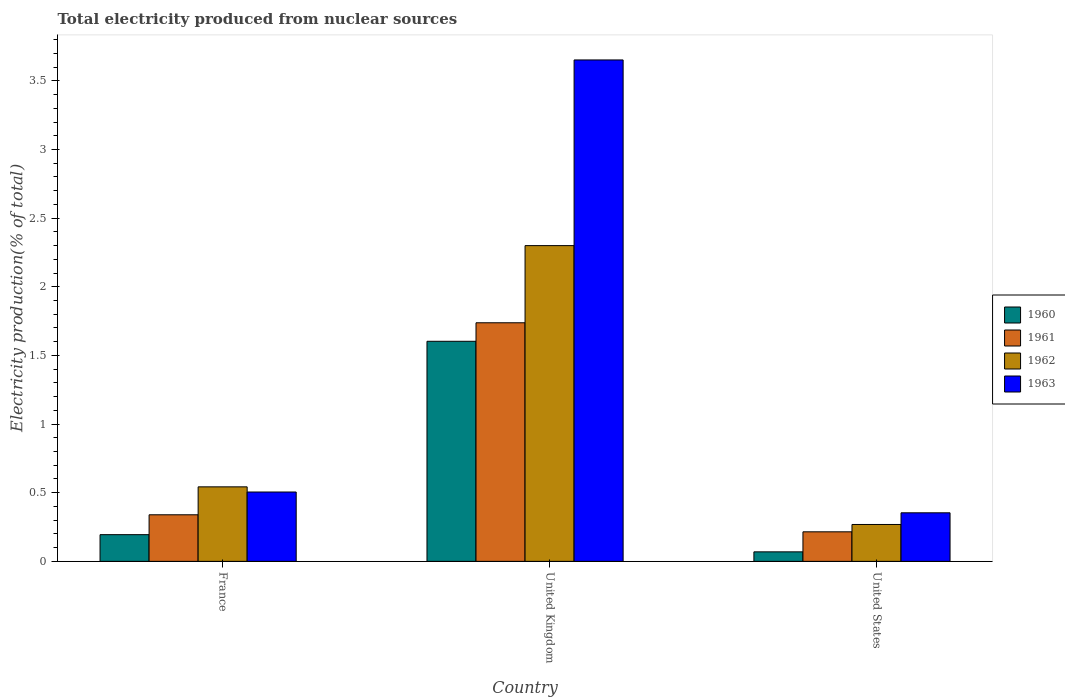How many different coloured bars are there?
Your response must be concise. 4. Are the number of bars on each tick of the X-axis equal?
Offer a terse response. Yes. In how many cases, is the number of bars for a given country not equal to the number of legend labels?
Offer a very short reply. 0. What is the total electricity produced in 1962 in United Kingdom?
Provide a short and direct response. 2.3. Across all countries, what is the maximum total electricity produced in 1962?
Give a very brief answer. 2.3. Across all countries, what is the minimum total electricity produced in 1962?
Your answer should be compact. 0.27. In which country was the total electricity produced in 1960 maximum?
Offer a very short reply. United Kingdom. What is the total total electricity produced in 1960 in the graph?
Offer a very short reply. 1.87. What is the difference between the total electricity produced in 1961 in France and that in United States?
Your answer should be very brief. 0.12. What is the difference between the total electricity produced in 1962 in France and the total electricity produced in 1961 in United Kingdom?
Provide a succinct answer. -1.2. What is the average total electricity produced in 1963 per country?
Your response must be concise. 1.5. What is the difference between the total electricity produced of/in 1961 and total electricity produced of/in 1963 in United Kingdom?
Make the answer very short. -1.91. In how many countries, is the total electricity produced in 1961 greater than 3.6 %?
Ensure brevity in your answer.  0. What is the ratio of the total electricity produced in 1962 in France to that in United States?
Give a very brief answer. 2.02. Is the difference between the total electricity produced in 1961 in United Kingdom and United States greater than the difference between the total electricity produced in 1963 in United Kingdom and United States?
Your response must be concise. No. What is the difference between the highest and the second highest total electricity produced in 1962?
Provide a short and direct response. 0.27. What is the difference between the highest and the lowest total electricity produced in 1961?
Make the answer very short. 1.52. In how many countries, is the total electricity produced in 1962 greater than the average total electricity produced in 1962 taken over all countries?
Make the answer very short. 1. How many bars are there?
Your answer should be compact. 12. What is the difference between two consecutive major ticks on the Y-axis?
Offer a very short reply. 0.5. Are the values on the major ticks of Y-axis written in scientific E-notation?
Ensure brevity in your answer.  No. Does the graph contain any zero values?
Your answer should be compact. No. Does the graph contain grids?
Ensure brevity in your answer.  No. How are the legend labels stacked?
Make the answer very short. Vertical. What is the title of the graph?
Ensure brevity in your answer.  Total electricity produced from nuclear sources. Does "2001" appear as one of the legend labels in the graph?
Provide a short and direct response. No. What is the label or title of the Y-axis?
Give a very brief answer. Electricity production(% of total). What is the Electricity production(% of total) of 1960 in France?
Offer a terse response. 0.19. What is the Electricity production(% of total) of 1961 in France?
Give a very brief answer. 0.34. What is the Electricity production(% of total) in 1962 in France?
Make the answer very short. 0.54. What is the Electricity production(% of total) in 1963 in France?
Keep it short and to the point. 0.51. What is the Electricity production(% of total) in 1960 in United Kingdom?
Provide a short and direct response. 1.6. What is the Electricity production(% of total) of 1961 in United Kingdom?
Your response must be concise. 1.74. What is the Electricity production(% of total) of 1962 in United Kingdom?
Offer a terse response. 2.3. What is the Electricity production(% of total) of 1963 in United Kingdom?
Offer a terse response. 3.65. What is the Electricity production(% of total) of 1960 in United States?
Offer a terse response. 0.07. What is the Electricity production(% of total) in 1961 in United States?
Ensure brevity in your answer.  0.22. What is the Electricity production(% of total) of 1962 in United States?
Provide a succinct answer. 0.27. What is the Electricity production(% of total) in 1963 in United States?
Provide a short and direct response. 0.35. Across all countries, what is the maximum Electricity production(% of total) of 1960?
Your response must be concise. 1.6. Across all countries, what is the maximum Electricity production(% of total) of 1961?
Ensure brevity in your answer.  1.74. Across all countries, what is the maximum Electricity production(% of total) of 1962?
Offer a very short reply. 2.3. Across all countries, what is the maximum Electricity production(% of total) of 1963?
Ensure brevity in your answer.  3.65. Across all countries, what is the minimum Electricity production(% of total) in 1960?
Make the answer very short. 0.07. Across all countries, what is the minimum Electricity production(% of total) of 1961?
Your answer should be compact. 0.22. Across all countries, what is the minimum Electricity production(% of total) of 1962?
Provide a short and direct response. 0.27. Across all countries, what is the minimum Electricity production(% of total) in 1963?
Your answer should be compact. 0.35. What is the total Electricity production(% of total) of 1960 in the graph?
Offer a very short reply. 1.87. What is the total Electricity production(% of total) in 1961 in the graph?
Your answer should be very brief. 2.29. What is the total Electricity production(% of total) in 1962 in the graph?
Offer a very short reply. 3.11. What is the total Electricity production(% of total) of 1963 in the graph?
Your answer should be compact. 4.51. What is the difference between the Electricity production(% of total) of 1960 in France and that in United Kingdom?
Your response must be concise. -1.41. What is the difference between the Electricity production(% of total) in 1961 in France and that in United Kingdom?
Offer a terse response. -1.4. What is the difference between the Electricity production(% of total) of 1962 in France and that in United Kingdom?
Offer a very short reply. -1.76. What is the difference between the Electricity production(% of total) in 1963 in France and that in United Kingdom?
Provide a short and direct response. -3.15. What is the difference between the Electricity production(% of total) of 1960 in France and that in United States?
Give a very brief answer. 0.13. What is the difference between the Electricity production(% of total) of 1961 in France and that in United States?
Provide a short and direct response. 0.12. What is the difference between the Electricity production(% of total) in 1962 in France and that in United States?
Your answer should be compact. 0.27. What is the difference between the Electricity production(% of total) in 1963 in France and that in United States?
Your answer should be very brief. 0.15. What is the difference between the Electricity production(% of total) of 1960 in United Kingdom and that in United States?
Offer a very short reply. 1.53. What is the difference between the Electricity production(% of total) in 1961 in United Kingdom and that in United States?
Your answer should be very brief. 1.52. What is the difference between the Electricity production(% of total) in 1962 in United Kingdom and that in United States?
Give a very brief answer. 2.03. What is the difference between the Electricity production(% of total) of 1963 in United Kingdom and that in United States?
Your answer should be compact. 3.3. What is the difference between the Electricity production(% of total) in 1960 in France and the Electricity production(% of total) in 1961 in United Kingdom?
Your answer should be very brief. -1.54. What is the difference between the Electricity production(% of total) in 1960 in France and the Electricity production(% of total) in 1962 in United Kingdom?
Give a very brief answer. -2.11. What is the difference between the Electricity production(% of total) in 1960 in France and the Electricity production(% of total) in 1963 in United Kingdom?
Keep it short and to the point. -3.46. What is the difference between the Electricity production(% of total) in 1961 in France and the Electricity production(% of total) in 1962 in United Kingdom?
Make the answer very short. -1.96. What is the difference between the Electricity production(% of total) in 1961 in France and the Electricity production(% of total) in 1963 in United Kingdom?
Provide a short and direct response. -3.31. What is the difference between the Electricity production(% of total) in 1962 in France and the Electricity production(% of total) in 1963 in United Kingdom?
Provide a short and direct response. -3.11. What is the difference between the Electricity production(% of total) of 1960 in France and the Electricity production(% of total) of 1961 in United States?
Your response must be concise. -0.02. What is the difference between the Electricity production(% of total) of 1960 in France and the Electricity production(% of total) of 1962 in United States?
Offer a very short reply. -0.07. What is the difference between the Electricity production(% of total) of 1960 in France and the Electricity production(% of total) of 1963 in United States?
Keep it short and to the point. -0.16. What is the difference between the Electricity production(% of total) in 1961 in France and the Electricity production(% of total) in 1962 in United States?
Ensure brevity in your answer.  0.07. What is the difference between the Electricity production(% of total) of 1961 in France and the Electricity production(% of total) of 1963 in United States?
Provide a succinct answer. -0.01. What is the difference between the Electricity production(% of total) of 1962 in France and the Electricity production(% of total) of 1963 in United States?
Provide a succinct answer. 0.19. What is the difference between the Electricity production(% of total) in 1960 in United Kingdom and the Electricity production(% of total) in 1961 in United States?
Provide a short and direct response. 1.39. What is the difference between the Electricity production(% of total) in 1960 in United Kingdom and the Electricity production(% of total) in 1962 in United States?
Your answer should be very brief. 1.33. What is the difference between the Electricity production(% of total) in 1960 in United Kingdom and the Electricity production(% of total) in 1963 in United States?
Your answer should be compact. 1.25. What is the difference between the Electricity production(% of total) in 1961 in United Kingdom and the Electricity production(% of total) in 1962 in United States?
Make the answer very short. 1.47. What is the difference between the Electricity production(% of total) in 1961 in United Kingdom and the Electricity production(% of total) in 1963 in United States?
Offer a terse response. 1.38. What is the difference between the Electricity production(% of total) in 1962 in United Kingdom and the Electricity production(% of total) in 1963 in United States?
Keep it short and to the point. 1.95. What is the average Electricity production(% of total) of 1960 per country?
Your answer should be very brief. 0.62. What is the average Electricity production(% of total) of 1961 per country?
Make the answer very short. 0.76. What is the average Electricity production(% of total) of 1962 per country?
Ensure brevity in your answer.  1.04. What is the average Electricity production(% of total) in 1963 per country?
Keep it short and to the point. 1.5. What is the difference between the Electricity production(% of total) in 1960 and Electricity production(% of total) in 1961 in France?
Ensure brevity in your answer.  -0.14. What is the difference between the Electricity production(% of total) in 1960 and Electricity production(% of total) in 1962 in France?
Offer a very short reply. -0.35. What is the difference between the Electricity production(% of total) in 1960 and Electricity production(% of total) in 1963 in France?
Give a very brief answer. -0.31. What is the difference between the Electricity production(% of total) of 1961 and Electricity production(% of total) of 1962 in France?
Keep it short and to the point. -0.2. What is the difference between the Electricity production(% of total) in 1961 and Electricity production(% of total) in 1963 in France?
Your answer should be compact. -0.17. What is the difference between the Electricity production(% of total) in 1962 and Electricity production(% of total) in 1963 in France?
Give a very brief answer. 0.04. What is the difference between the Electricity production(% of total) in 1960 and Electricity production(% of total) in 1961 in United Kingdom?
Make the answer very short. -0.13. What is the difference between the Electricity production(% of total) in 1960 and Electricity production(% of total) in 1962 in United Kingdom?
Offer a very short reply. -0.7. What is the difference between the Electricity production(% of total) in 1960 and Electricity production(% of total) in 1963 in United Kingdom?
Offer a very short reply. -2.05. What is the difference between the Electricity production(% of total) of 1961 and Electricity production(% of total) of 1962 in United Kingdom?
Provide a short and direct response. -0.56. What is the difference between the Electricity production(% of total) in 1961 and Electricity production(% of total) in 1963 in United Kingdom?
Ensure brevity in your answer.  -1.91. What is the difference between the Electricity production(% of total) of 1962 and Electricity production(% of total) of 1963 in United Kingdom?
Offer a terse response. -1.35. What is the difference between the Electricity production(% of total) of 1960 and Electricity production(% of total) of 1961 in United States?
Provide a succinct answer. -0.15. What is the difference between the Electricity production(% of total) of 1960 and Electricity production(% of total) of 1962 in United States?
Your response must be concise. -0.2. What is the difference between the Electricity production(% of total) in 1960 and Electricity production(% of total) in 1963 in United States?
Offer a very short reply. -0.28. What is the difference between the Electricity production(% of total) of 1961 and Electricity production(% of total) of 1962 in United States?
Provide a short and direct response. -0.05. What is the difference between the Electricity production(% of total) in 1961 and Electricity production(% of total) in 1963 in United States?
Offer a very short reply. -0.14. What is the difference between the Electricity production(% of total) in 1962 and Electricity production(% of total) in 1963 in United States?
Ensure brevity in your answer.  -0.09. What is the ratio of the Electricity production(% of total) in 1960 in France to that in United Kingdom?
Make the answer very short. 0.12. What is the ratio of the Electricity production(% of total) in 1961 in France to that in United Kingdom?
Give a very brief answer. 0.2. What is the ratio of the Electricity production(% of total) of 1962 in France to that in United Kingdom?
Your answer should be very brief. 0.24. What is the ratio of the Electricity production(% of total) of 1963 in France to that in United Kingdom?
Ensure brevity in your answer.  0.14. What is the ratio of the Electricity production(% of total) of 1960 in France to that in United States?
Give a very brief answer. 2.81. What is the ratio of the Electricity production(% of total) in 1961 in France to that in United States?
Ensure brevity in your answer.  1.58. What is the ratio of the Electricity production(% of total) of 1962 in France to that in United States?
Ensure brevity in your answer.  2.02. What is the ratio of the Electricity production(% of total) of 1963 in France to that in United States?
Ensure brevity in your answer.  1.43. What is the ratio of the Electricity production(% of total) of 1960 in United Kingdom to that in United States?
Make the answer very short. 23.14. What is the ratio of the Electricity production(% of total) in 1961 in United Kingdom to that in United States?
Your answer should be compact. 8.08. What is the ratio of the Electricity production(% of total) in 1962 in United Kingdom to that in United States?
Your response must be concise. 8.56. What is the ratio of the Electricity production(% of total) in 1963 in United Kingdom to that in United States?
Provide a short and direct response. 10.32. What is the difference between the highest and the second highest Electricity production(% of total) in 1960?
Provide a short and direct response. 1.41. What is the difference between the highest and the second highest Electricity production(% of total) in 1961?
Ensure brevity in your answer.  1.4. What is the difference between the highest and the second highest Electricity production(% of total) of 1962?
Give a very brief answer. 1.76. What is the difference between the highest and the second highest Electricity production(% of total) of 1963?
Give a very brief answer. 3.15. What is the difference between the highest and the lowest Electricity production(% of total) of 1960?
Your answer should be very brief. 1.53. What is the difference between the highest and the lowest Electricity production(% of total) in 1961?
Offer a very short reply. 1.52. What is the difference between the highest and the lowest Electricity production(% of total) in 1962?
Offer a very short reply. 2.03. What is the difference between the highest and the lowest Electricity production(% of total) of 1963?
Provide a short and direct response. 3.3. 